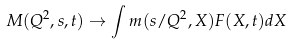Convert formula to latex. <formula><loc_0><loc_0><loc_500><loc_500>M ( Q ^ { 2 } , s , t ) \to \int m ( s / Q ^ { 2 } , X ) F ( X , t ) d X</formula> 